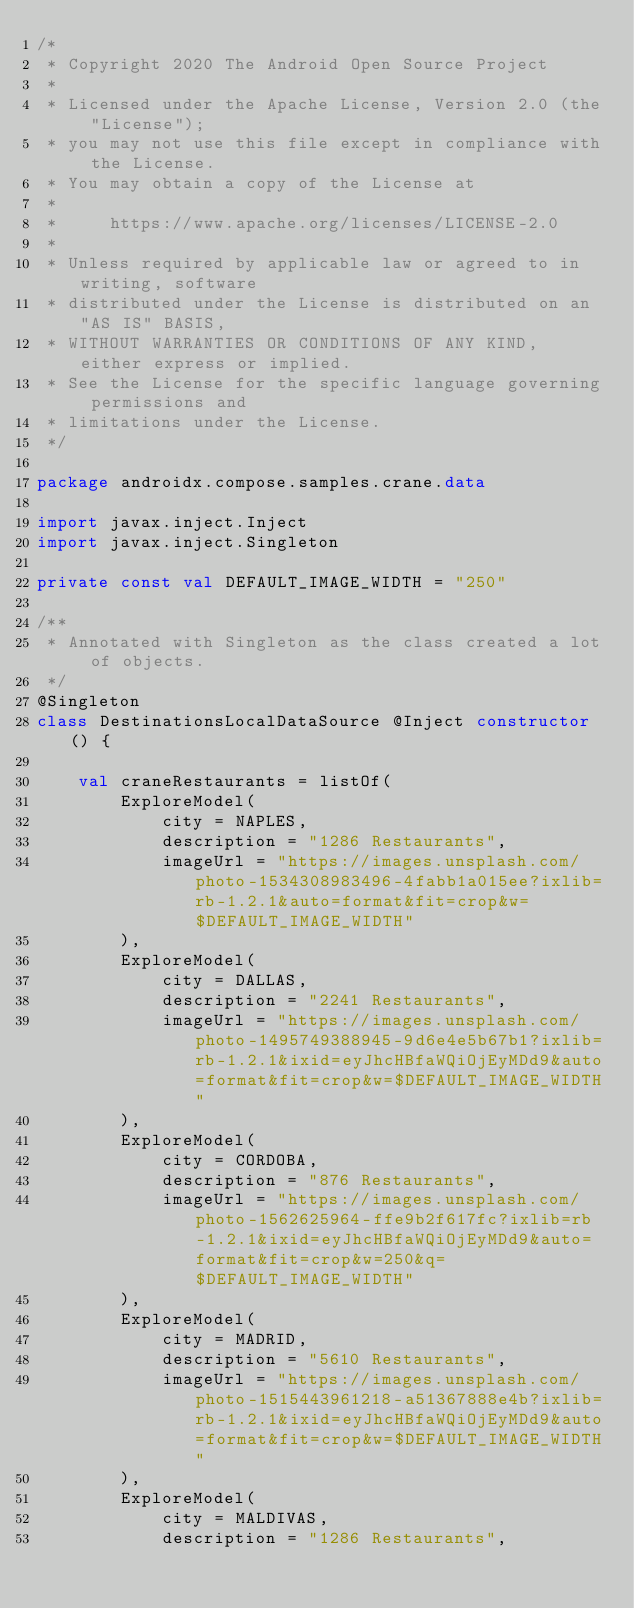<code> <loc_0><loc_0><loc_500><loc_500><_Kotlin_>/*
 * Copyright 2020 The Android Open Source Project
 *
 * Licensed under the Apache License, Version 2.0 (the "License");
 * you may not use this file except in compliance with the License.
 * You may obtain a copy of the License at
 *
 *     https://www.apache.org/licenses/LICENSE-2.0
 *
 * Unless required by applicable law or agreed to in writing, software
 * distributed under the License is distributed on an "AS IS" BASIS,
 * WITHOUT WARRANTIES OR CONDITIONS OF ANY KIND, either express or implied.
 * See the License for the specific language governing permissions and
 * limitations under the License.
 */

package androidx.compose.samples.crane.data

import javax.inject.Inject
import javax.inject.Singleton

private const val DEFAULT_IMAGE_WIDTH = "250"

/**
 * Annotated with Singleton as the class created a lot of objects.
 */
@Singleton
class DestinationsLocalDataSource @Inject constructor() {

    val craneRestaurants = listOf(
        ExploreModel(
            city = NAPLES,
            description = "1286 Restaurants",
            imageUrl = "https://images.unsplash.com/photo-1534308983496-4fabb1a015ee?ixlib=rb-1.2.1&auto=format&fit=crop&w=$DEFAULT_IMAGE_WIDTH"
        ),
        ExploreModel(
            city = DALLAS,
            description = "2241 Restaurants",
            imageUrl = "https://images.unsplash.com/photo-1495749388945-9d6e4e5b67b1?ixlib=rb-1.2.1&ixid=eyJhcHBfaWQiOjEyMDd9&auto=format&fit=crop&w=$DEFAULT_IMAGE_WIDTH"
        ),
        ExploreModel(
            city = CORDOBA,
            description = "876 Restaurants",
            imageUrl = "https://images.unsplash.com/photo-1562625964-ffe9b2f617fc?ixlib=rb-1.2.1&ixid=eyJhcHBfaWQiOjEyMDd9&auto=format&fit=crop&w=250&q=$DEFAULT_IMAGE_WIDTH"
        ),
        ExploreModel(
            city = MADRID,
            description = "5610 Restaurants",
            imageUrl = "https://images.unsplash.com/photo-1515443961218-a51367888e4b?ixlib=rb-1.2.1&ixid=eyJhcHBfaWQiOjEyMDd9&auto=format&fit=crop&w=$DEFAULT_IMAGE_WIDTH"
        ),
        ExploreModel(
            city = MALDIVAS,
            description = "1286 Restaurants",</code> 